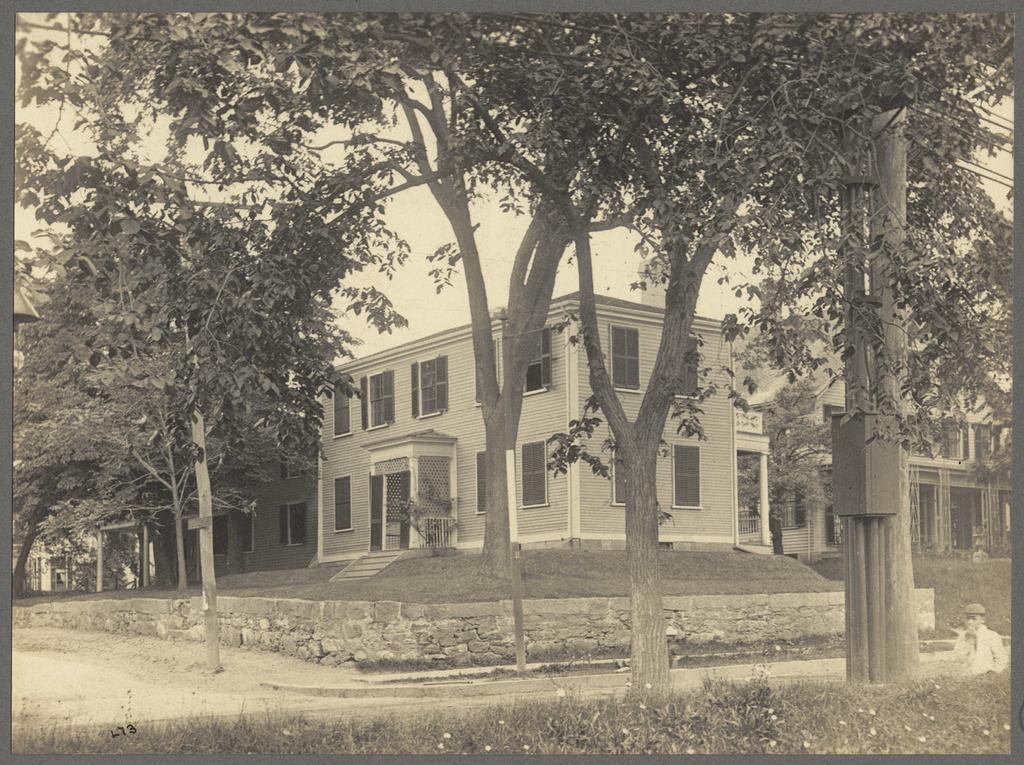Describe this image in one or two sentences. This is a black and white image. In this image we can see houses, trees. At the bottom of the image there is grass. 